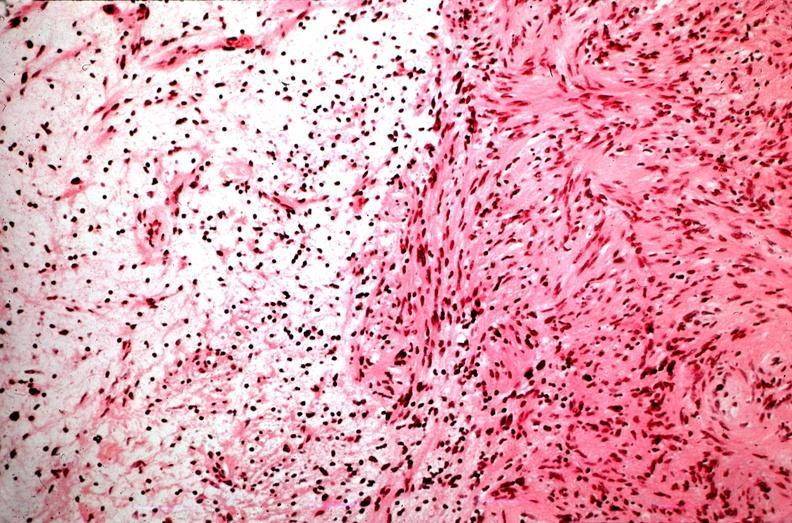does this image show schwannoma, antoni a and antoni b patterns?
Answer the question using a single word or phrase. Yes 